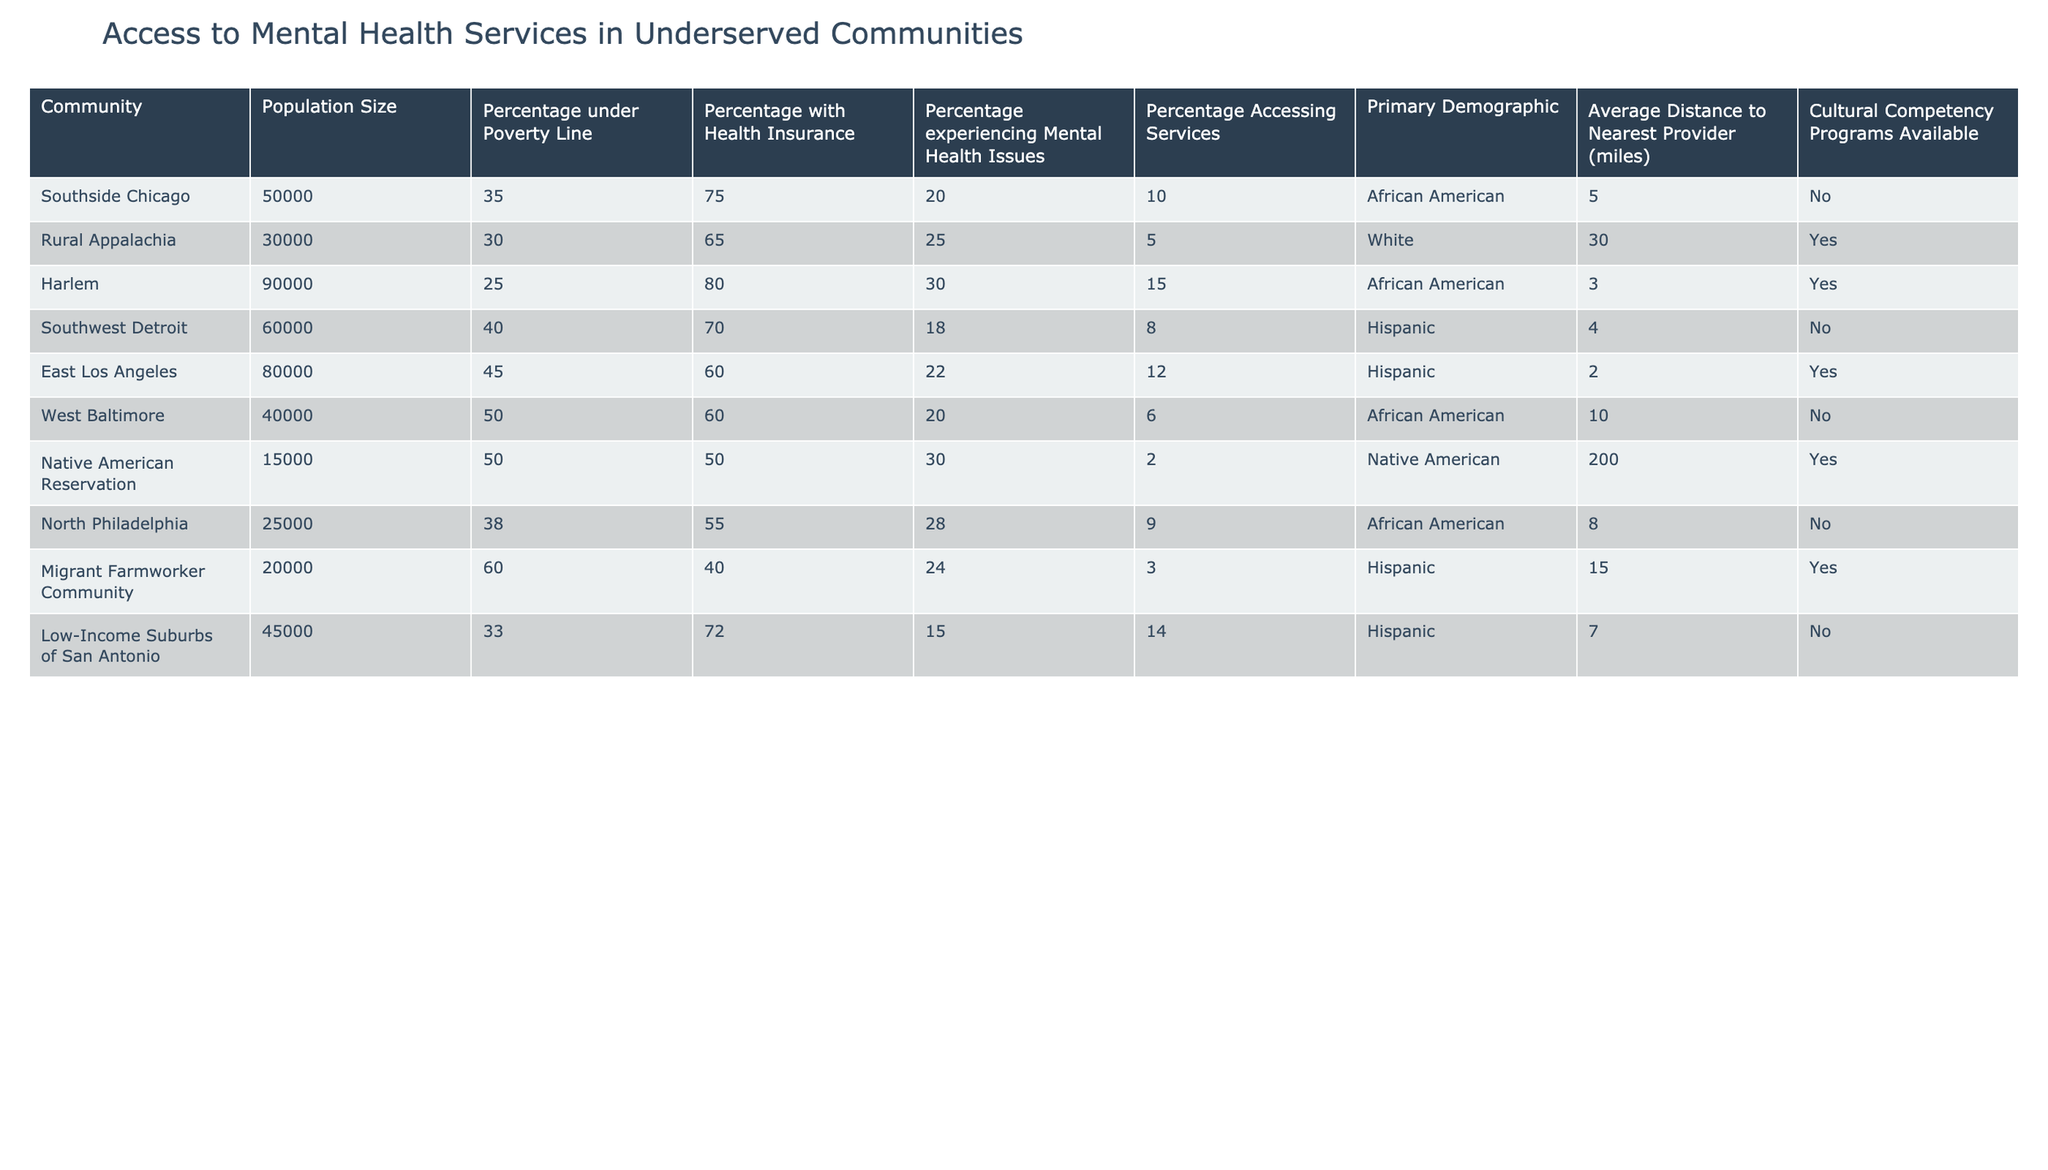What is the population size of Southside Chicago? The population size for Southside Chicago is directly stated in the table under the "Population Size" column. It is listed as 50,000.
Answer: 50,000 Which community has the highest percentage of individuals under the poverty line? By examining the "Percentage under Poverty Line" column, West Baltimore shows the highest percentage at 50%.
Answer: 50% How many communities have cultural competency programs available? The "Cultural Competency Programs Available" column shows that 4 communities have these programs. These are Rural Appalachia, Harlem, Native American Reservation, and Migrant Farmworker Community.
Answer: 4 What is the average distance to the nearest provider for communities with less than 20% accessing mental health services? The communities with less than 20% accessing services are Southside Chicago (10%), Southwest Detroit (8%), and West Baltimore (6%). The average distance to the nearest provider is (5 + 4 + 10) / 3 = 6.33 miles.
Answer: 6.33 miles Is there any community with a high percentage of individuals experiencing mental health issues but low access to services? The community of Southside Chicago has 20% experiencing mental health issues but only 10% accessing services, indicating a discrepancy between need and access.
Answer: Yes 